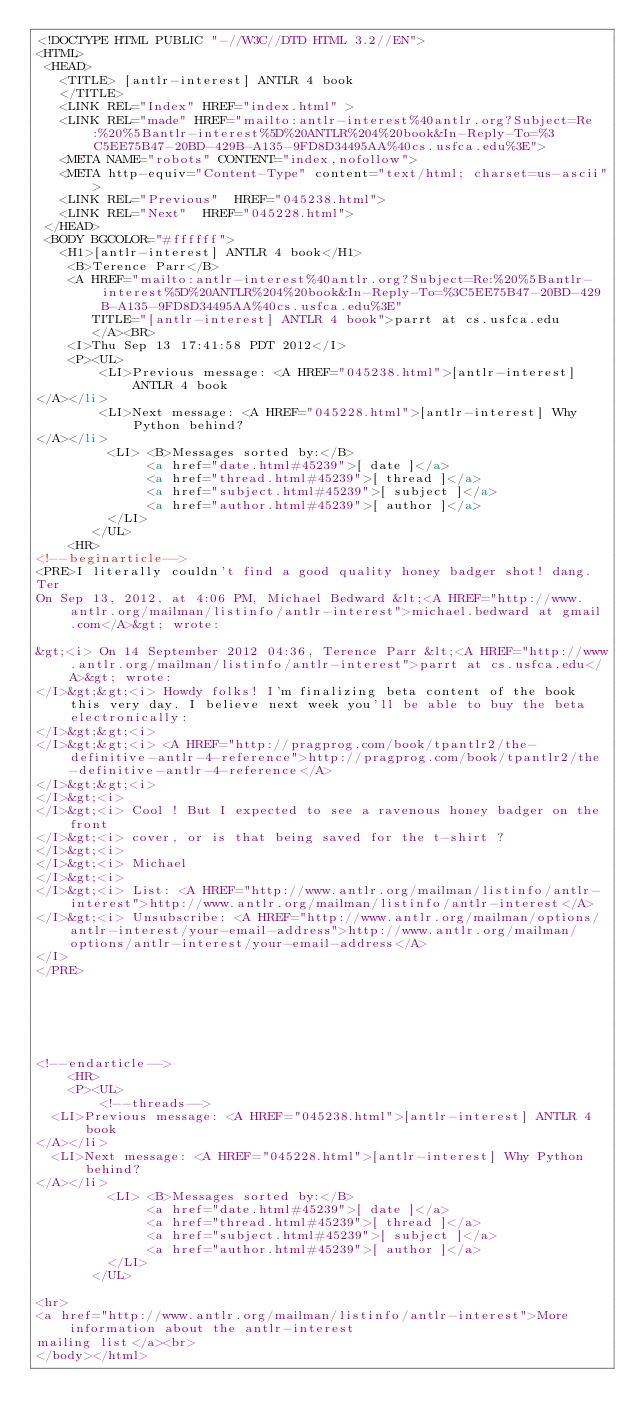Convert code to text. <code><loc_0><loc_0><loc_500><loc_500><_HTML_><!DOCTYPE HTML PUBLIC "-//W3C//DTD HTML 3.2//EN">
<HTML>
 <HEAD>
   <TITLE> [antlr-interest] ANTLR 4 book
   </TITLE>
   <LINK REL="Index" HREF="index.html" >
   <LINK REL="made" HREF="mailto:antlr-interest%40antlr.org?Subject=Re:%20%5Bantlr-interest%5D%20ANTLR%204%20book&In-Reply-To=%3C5EE75B47-20BD-429B-A135-9FD8D34495AA%40cs.usfca.edu%3E">
   <META NAME="robots" CONTENT="index,nofollow">
   <META http-equiv="Content-Type" content="text/html; charset=us-ascii">
   <LINK REL="Previous"  HREF="045238.html">
   <LINK REL="Next"  HREF="045228.html">
 </HEAD>
 <BODY BGCOLOR="#ffffff">
   <H1>[antlr-interest] ANTLR 4 book</H1>
    <B>Terence Parr</B> 
    <A HREF="mailto:antlr-interest%40antlr.org?Subject=Re:%20%5Bantlr-interest%5D%20ANTLR%204%20book&In-Reply-To=%3C5EE75B47-20BD-429B-A135-9FD8D34495AA%40cs.usfca.edu%3E"
       TITLE="[antlr-interest] ANTLR 4 book">parrt at cs.usfca.edu
       </A><BR>
    <I>Thu Sep 13 17:41:58 PDT 2012</I>
    <P><UL>
        <LI>Previous message: <A HREF="045238.html">[antlr-interest] ANTLR 4 book
</A></li>
        <LI>Next message: <A HREF="045228.html">[antlr-interest] Why Python behind?
</A></li>
         <LI> <B>Messages sorted by:</B> 
              <a href="date.html#45239">[ date ]</a>
              <a href="thread.html#45239">[ thread ]</a>
              <a href="subject.html#45239">[ subject ]</a>
              <a href="author.html#45239">[ author ]</a>
         </LI>
       </UL>
    <HR>  
<!--beginarticle-->
<PRE>I literally couldn't find a good quality honey badger shot! dang.
Ter
On Sep 13, 2012, at 4:06 PM, Michael Bedward &lt;<A HREF="http://www.antlr.org/mailman/listinfo/antlr-interest">michael.bedward at gmail.com</A>&gt; wrote:

&gt;<i> On 14 September 2012 04:36, Terence Parr &lt;<A HREF="http://www.antlr.org/mailman/listinfo/antlr-interest">parrt at cs.usfca.edu</A>&gt; wrote:
</I>&gt;&gt;<i> Howdy folks! I'm finalizing beta content of the book this very day. I believe next week you'll be able to buy the beta electronically:
</I>&gt;&gt;<i> 
</I>&gt;&gt;<i> <A HREF="http://pragprog.com/book/tpantlr2/the-definitive-antlr-4-reference">http://pragprog.com/book/tpantlr2/the-definitive-antlr-4-reference</A>
</I>&gt;&gt;<i> 
</I>&gt;<i> 
</I>&gt;<i> Cool ! But I expected to see a ravenous honey badger on the front
</I>&gt;<i> cover, or is that being saved for the t-shirt ?
</I>&gt;<i> 
</I>&gt;<i> Michael
</I>&gt;<i> 
</I>&gt;<i> List: <A HREF="http://www.antlr.org/mailman/listinfo/antlr-interest">http://www.antlr.org/mailman/listinfo/antlr-interest</A>
</I>&gt;<i> Unsubscribe: <A HREF="http://www.antlr.org/mailman/options/antlr-interest/your-email-address">http://www.antlr.org/mailman/options/antlr-interest/your-email-address</A>
</I>
</PRE>






<!--endarticle-->
    <HR>
    <P><UL>
        <!--threads-->
	<LI>Previous message: <A HREF="045238.html">[antlr-interest] ANTLR 4 book
</A></li>
	<LI>Next message: <A HREF="045228.html">[antlr-interest] Why Python behind?
</A></li>
         <LI> <B>Messages sorted by:</B> 
              <a href="date.html#45239">[ date ]</a>
              <a href="thread.html#45239">[ thread ]</a>
              <a href="subject.html#45239">[ subject ]</a>
              <a href="author.html#45239">[ author ]</a>
         </LI>
       </UL>

<hr>
<a href="http://www.antlr.org/mailman/listinfo/antlr-interest">More information about the antlr-interest
mailing list</a><br>
</body></html>
</code> 